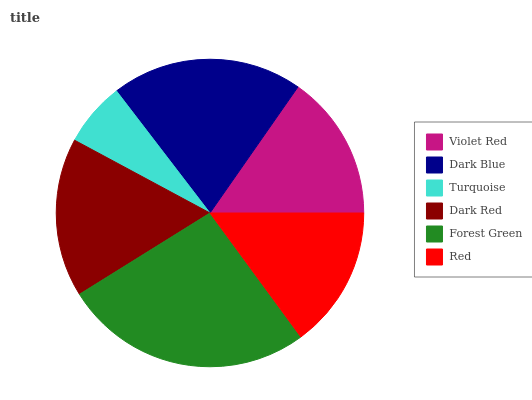Is Turquoise the minimum?
Answer yes or no. Yes. Is Forest Green the maximum?
Answer yes or no. Yes. Is Dark Blue the minimum?
Answer yes or no. No. Is Dark Blue the maximum?
Answer yes or no. No. Is Dark Blue greater than Violet Red?
Answer yes or no. Yes. Is Violet Red less than Dark Blue?
Answer yes or no. Yes. Is Violet Red greater than Dark Blue?
Answer yes or no. No. Is Dark Blue less than Violet Red?
Answer yes or no. No. Is Dark Red the high median?
Answer yes or no. Yes. Is Violet Red the low median?
Answer yes or no. Yes. Is Turquoise the high median?
Answer yes or no. No. Is Turquoise the low median?
Answer yes or no. No. 